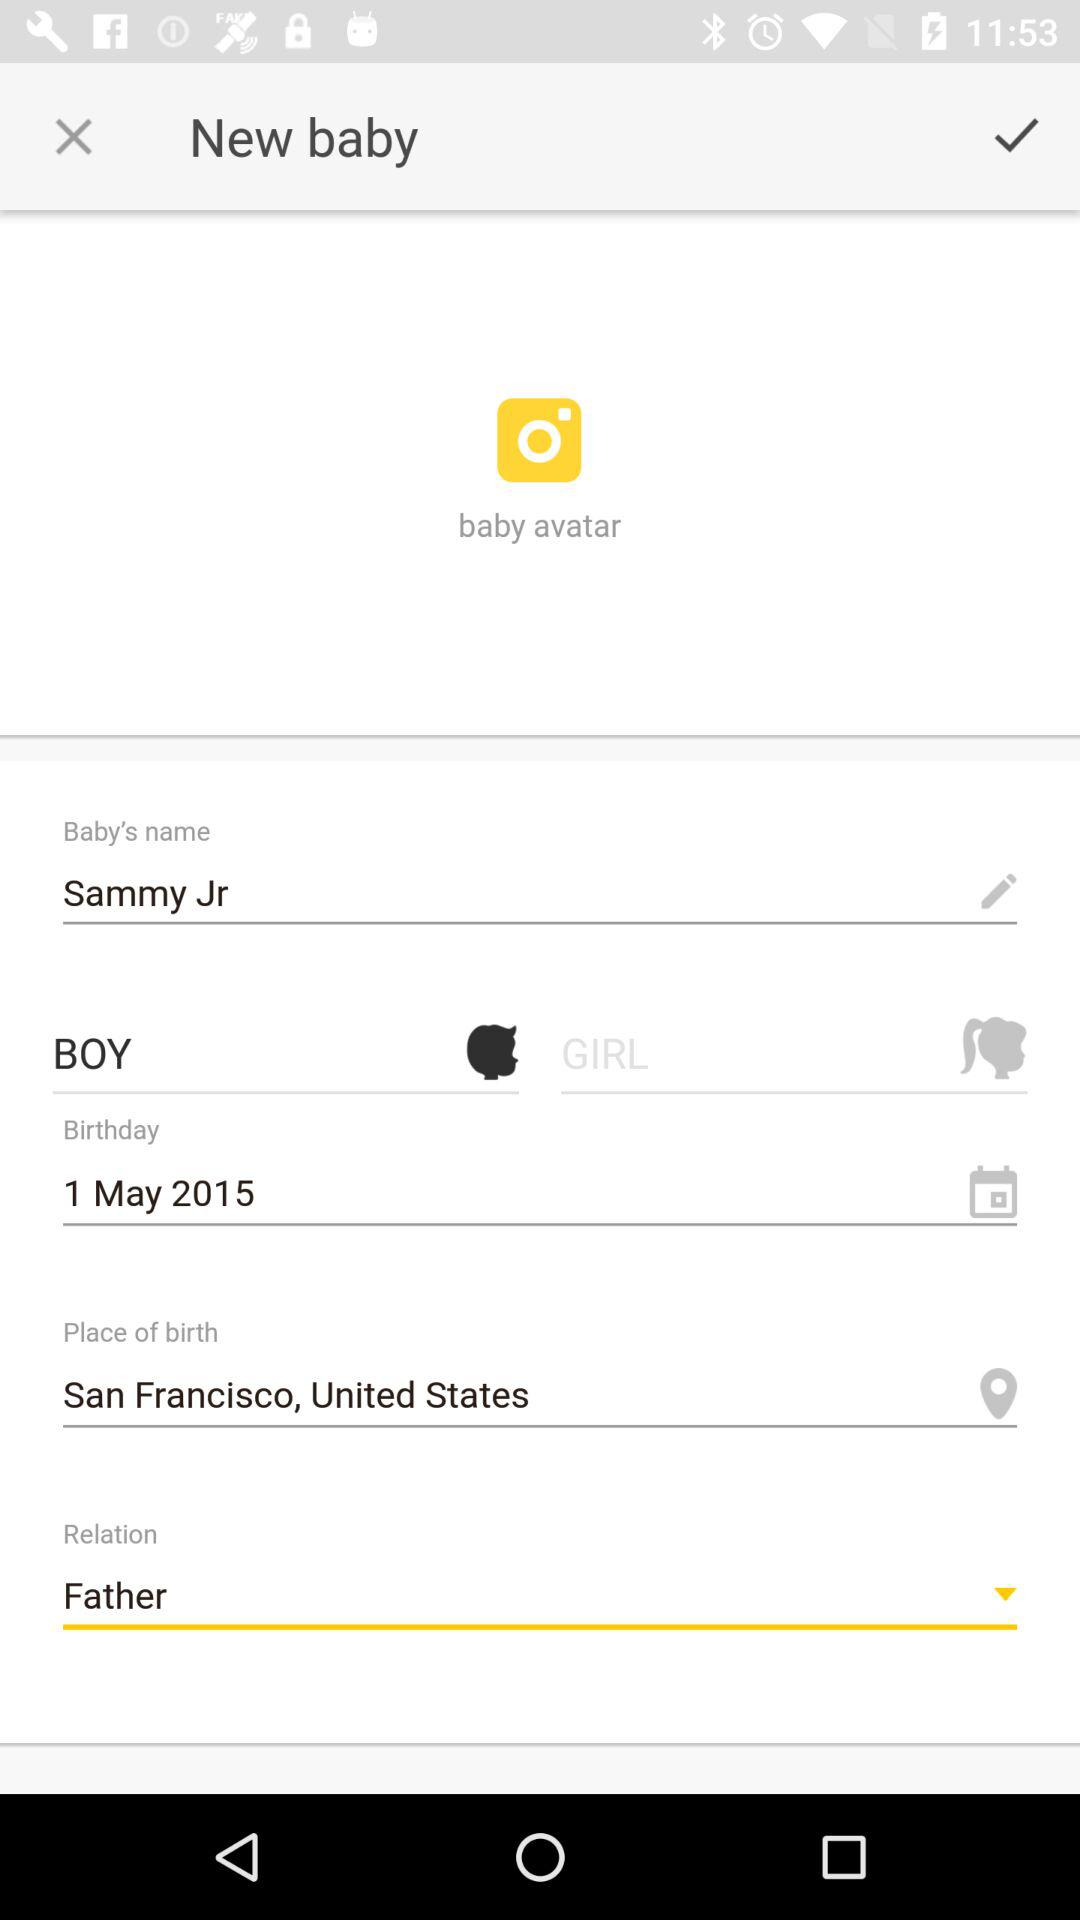What is the date of birth of the baby? The date of birth is May 1, 2015. 